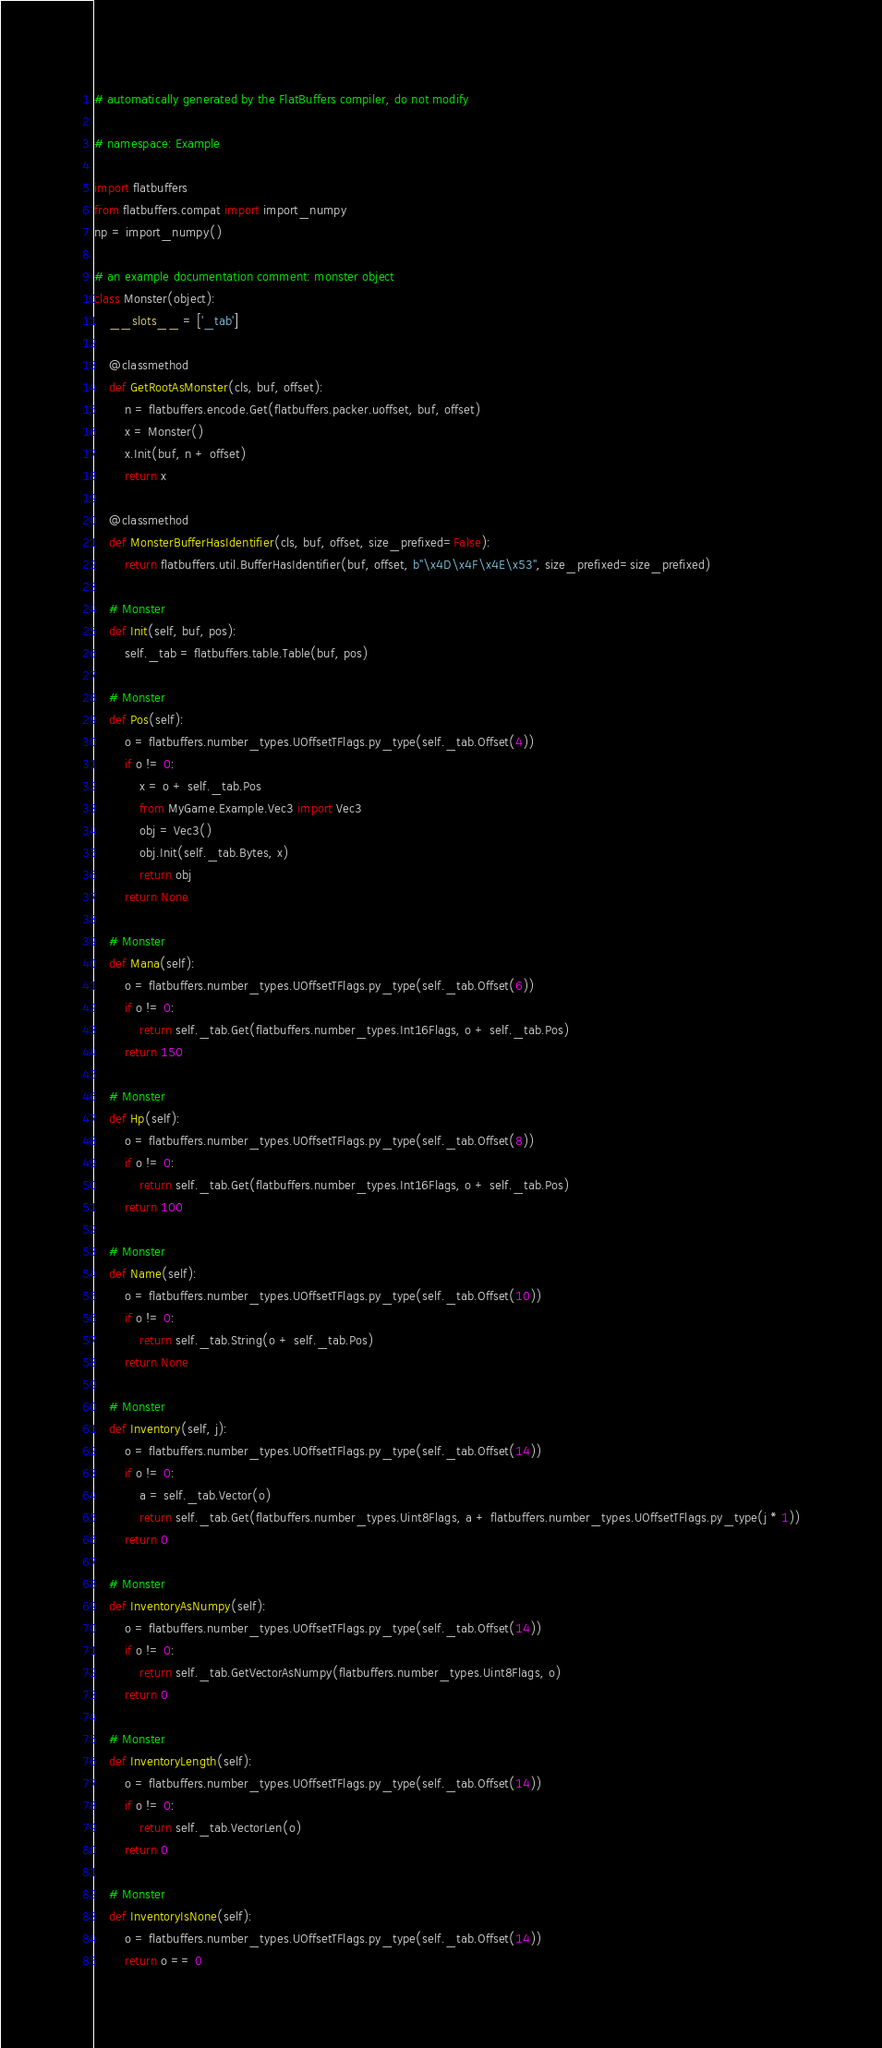Convert code to text. <code><loc_0><loc_0><loc_500><loc_500><_Python_># automatically generated by the FlatBuffers compiler, do not modify

# namespace: Example

import flatbuffers
from flatbuffers.compat import import_numpy
np = import_numpy()

# an example documentation comment: monster object
class Monster(object):
    __slots__ = ['_tab']

    @classmethod
    def GetRootAsMonster(cls, buf, offset):
        n = flatbuffers.encode.Get(flatbuffers.packer.uoffset, buf, offset)
        x = Monster()
        x.Init(buf, n + offset)
        return x

    @classmethod
    def MonsterBufferHasIdentifier(cls, buf, offset, size_prefixed=False):
        return flatbuffers.util.BufferHasIdentifier(buf, offset, b"\x4D\x4F\x4E\x53", size_prefixed=size_prefixed)

    # Monster
    def Init(self, buf, pos):
        self._tab = flatbuffers.table.Table(buf, pos)

    # Monster
    def Pos(self):
        o = flatbuffers.number_types.UOffsetTFlags.py_type(self._tab.Offset(4))
        if o != 0:
            x = o + self._tab.Pos
            from MyGame.Example.Vec3 import Vec3
            obj = Vec3()
            obj.Init(self._tab.Bytes, x)
            return obj
        return None

    # Monster
    def Mana(self):
        o = flatbuffers.number_types.UOffsetTFlags.py_type(self._tab.Offset(6))
        if o != 0:
            return self._tab.Get(flatbuffers.number_types.Int16Flags, o + self._tab.Pos)
        return 150

    # Monster
    def Hp(self):
        o = flatbuffers.number_types.UOffsetTFlags.py_type(self._tab.Offset(8))
        if o != 0:
            return self._tab.Get(flatbuffers.number_types.Int16Flags, o + self._tab.Pos)
        return 100

    # Monster
    def Name(self):
        o = flatbuffers.number_types.UOffsetTFlags.py_type(self._tab.Offset(10))
        if o != 0:
            return self._tab.String(o + self._tab.Pos)
        return None

    # Monster
    def Inventory(self, j):
        o = flatbuffers.number_types.UOffsetTFlags.py_type(self._tab.Offset(14))
        if o != 0:
            a = self._tab.Vector(o)
            return self._tab.Get(flatbuffers.number_types.Uint8Flags, a + flatbuffers.number_types.UOffsetTFlags.py_type(j * 1))
        return 0

    # Monster
    def InventoryAsNumpy(self):
        o = flatbuffers.number_types.UOffsetTFlags.py_type(self._tab.Offset(14))
        if o != 0:
            return self._tab.GetVectorAsNumpy(flatbuffers.number_types.Uint8Flags, o)
        return 0

    # Monster
    def InventoryLength(self):
        o = flatbuffers.number_types.UOffsetTFlags.py_type(self._tab.Offset(14))
        if o != 0:
            return self._tab.VectorLen(o)
        return 0

    # Monster
    def InventoryIsNone(self):
        o = flatbuffers.number_types.UOffsetTFlags.py_type(self._tab.Offset(14))
        return o == 0
</code> 